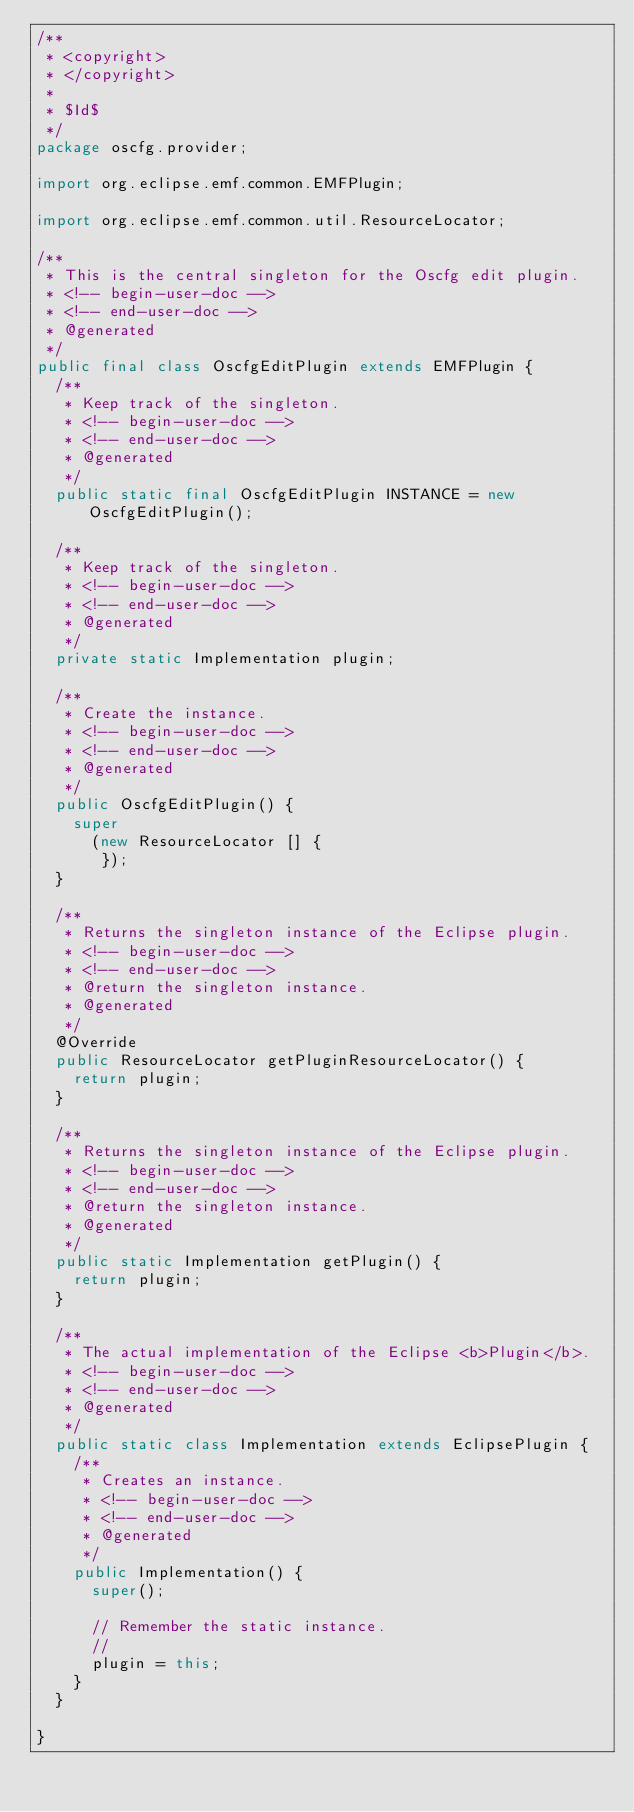<code> <loc_0><loc_0><loc_500><loc_500><_Java_>/**
 * <copyright>
 * </copyright>
 *
 * $Id$
 */
package oscfg.provider;

import org.eclipse.emf.common.EMFPlugin;

import org.eclipse.emf.common.util.ResourceLocator;

/**
 * This is the central singleton for the Oscfg edit plugin.
 * <!-- begin-user-doc -->
 * <!-- end-user-doc -->
 * @generated
 */
public final class OscfgEditPlugin extends EMFPlugin {
	/**
	 * Keep track of the singleton.
	 * <!-- begin-user-doc -->
	 * <!-- end-user-doc -->
	 * @generated
	 */
	public static final OscfgEditPlugin INSTANCE = new OscfgEditPlugin();

	/**
	 * Keep track of the singleton.
	 * <!-- begin-user-doc -->
	 * <!-- end-user-doc -->
	 * @generated
	 */
	private static Implementation plugin;

	/**
	 * Create the instance.
	 * <!-- begin-user-doc -->
	 * <!-- end-user-doc -->
	 * @generated
	 */
	public OscfgEditPlugin() {
		super
		  (new ResourceLocator [] {
		   });
	}

	/**
	 * Returns the singleton instance of the Eclipse plugin.
	 * <!-- begin-user-doc -->
	 * <!-- end-user-doc -->
	 * @return the singleton instance.
	 * @generated
	 */
	@Override
	public ResourceLocator getPluginResourceLocator() {
		return plugin;
	}

	/**
	 * Returns the singleton instance of the Eclipse plugin.
	 * <!-- begin-user-doc -->
	 * <!-- end-user-doc -->
	 * @return the singleton instance.
	 * @generated
	 */
	public static Implementation getPlugin() {
		return plugin;
	}

	/**
	 * The actual implementation of the Eclipse <b>Plugin</b>.
	 * <!-- begin-user-doc -->
	 * <!-- end-user-doc -->
	 * @generated
	 */
	public static class Implementation extends EclipsePlugin {
		/**
		 * Creates an instance.
		 * <!-- begin-user-doc -->
		 * <!-- end-user-doc -->
		 * @generated
		 */
		public Implementation() {
			super();

			// Remember the static instance.
			//
			plugin = this;
		}
	}

}
</code> 